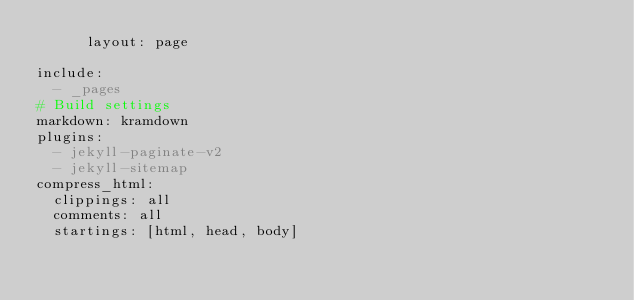Convert code to text. <code><loc_0><loc_0><loc_500><loc_500><_YAML_>      layout: page

include:
  - _pages
# Build settings
markdown: kramdown
plugins:
  - jekyll-paginate-v2
  - jekyll-sitemap
compress_html:
  clippings: all
  comments: all
  startings: [html, head, body]</code> 